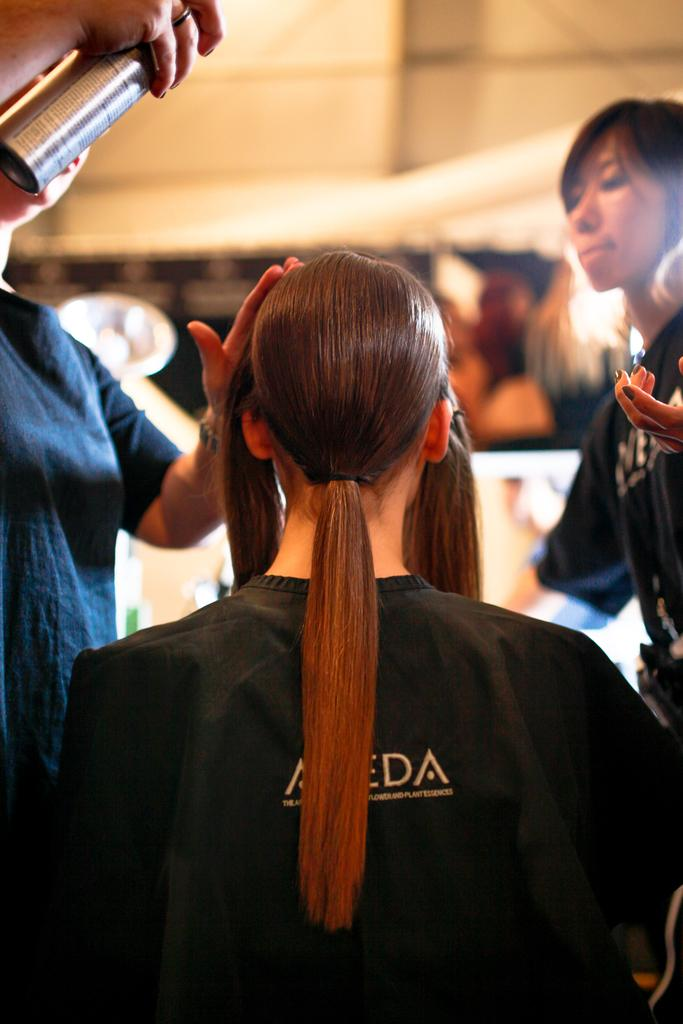Where are the people located in the image? There are people in the left side, right side, and foreground of the image. What can be seen in the background of the image? There is a wall in the background of the image. What is visible at the top of the image? There is a roof visible at the top of the image. What type of amusement can be seen in the image? There is no amusement present in the image; it features people in various locations and a wall in the background. Can you tell me how many copies of the same person are visible in the image? There are no copies of the same person visible in the image; each person is unique. 